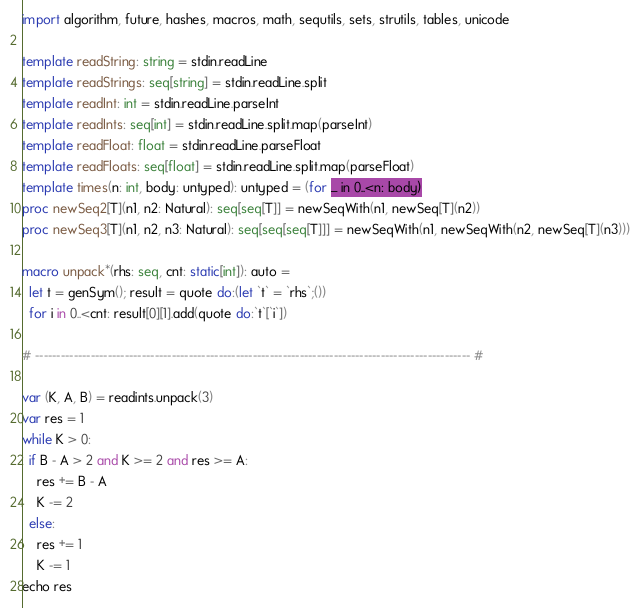Convert code to text. <code><loc_0><loc_0><loc_500><loc_500><_Nim_>import algorithm, future, hashes, macros, math, sequtils, sets, strutils, tables, unicode

template readString: string = stdin.readLine
template readStrings: seq[string] = stdin.readLine.split
template readInt: int = stdin.readLine.parseInt
template readInts: seq[int] = stdin.readLine.split.map(parseInt)
template readFloat: float = stdin.readLine.parseFloat
template readFloats: seq[float] = stdin.readLine.split.map(parseFloat)
template times(n: int, body: untyped): untyped = (for _ in 0..<n: body)
proc newSeq2[T](n1, n2: Natural): seq[seq[T]] = newSeqWith(n1, newSeq[T](n2))
proc newSeq3[T](n1, n2, n3: Natural): seq[seq[seq[T]]] = newSeqWith(n1, newSeqWith(n2, newSeq[T](n3)))

macro unpack*(rhs: seq, cnt: static[int]): auto =
  let t = genSym(); result = quote do:(let `t` = `rhs`;())
  for i in 0..<cnt: result[0][1].add(quote do:`t`[`i`])

# ------------------------------------------------------------------------------------------------------ #

var (K, A, B) = readints.unpack(3)
var res = 1
while K > 0:
  if B - A > 2 and K >= 2 and res >= A:
    res += B - A
    K -= 2
  else:
    res += 1
    K -= 1
echo res</code> 